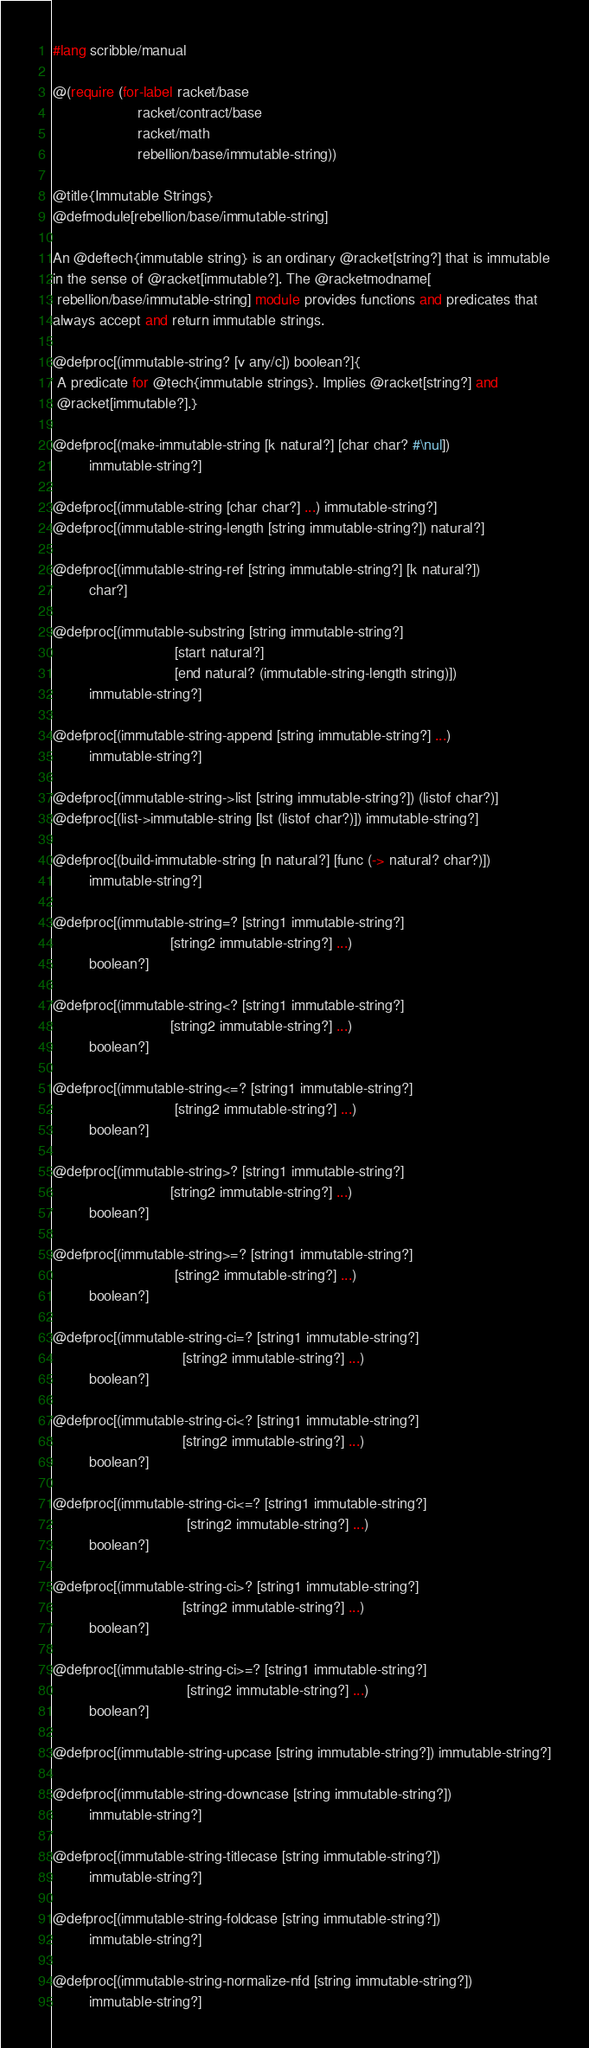Convert code to text. <code><loc_0><loc_0><loc_500><loc_500><_Racket_>#lang scribble/manual

@(require (for-label racket/base
                     racket/contract/base
                     racket/math
                     rebellion/base/immutable-string))

@title{Immutable Strings}
@defmodule[rebellion/base/immutable-string]

An @deftech{immutable string} is an ordinary @racket[string?] that is immutable
in the sense of @racket[immutable?]. The @racketmodname[
 rebellion/base/immutable-string] module provides functions and predicates that
always accept and return immutable strings.

@defproc[(immutable-string? [v any/c]) boolean?]{
 A predicate for @tech{immutable strings}. Implies @racket[string?] and
 @racket[immutable?].}

@defproc[(make-immutable-string [k natural?] [char char? #\nul])
         immutable-string?]

@defproc[(immutable-string [char char?] ...) immutable-string?]
@defproc[(immutable-string-length [string immutable-string?]) natural?]

@defproc[(immutable-string-ref [string immutable-string?] [k natural?])
         char?]

@defproc[(immutable-substring [string immutable-string?]
                              [start natural?]
                              [end natural? (immutable-string-length string)])
         immutable-string?]

@defproc[(immutable-string-append [string immutable-string?] ...)
         immutable-string?]

@defproc[(immutable-string->list [string immutable-string?]) (listof char?)]
@defproc[(list->immutable-string [lst (listof char?)]) immutable-string?]

@defproc[(build-immutable-string [n natural?] [func (-> natural? char?)])
         immutable-string?]

@defproc[(immutable-string=? [string1 immutable-string?]
                             [string2 immutable-string?] ...)
         boolean?]

@defproc[(immutable-string<? [string1 immutable-string?]
                             [string2 immutable-string?] ...)
         boolean?]

@defproc[(immutable-string<=? [string1 immutable-string?]
                              [string2 immutable-string?] ...)
         boolean?]

@defproc[(immutable-string>? [string1 immutable-string?]
                             [string2 immutable-string?] ...)
         boolean?]

@defproc[(immutable-string>=? [string1 immutable-string?]
                              [string2 immutable-string?] ...)
         boolean?]

@defproc[(immutable-string-ci=? [string1 immutable-string?]
                                [string2 immutable-string?] ...)
         boolean?]

@defproc[(immutable-string-ci<? [string1 immutable-string?]
                                [string2 immutable-string?] ...)
         boolean?]

@defproc[(immutable-string-ci<=? [string1 immutable-string?]
                                 [string2 immutable-string?] ...)
         boolean?]

@defproc[(immutable-string-ci>? [string1 immutable-string?]
                                [string2 immutable-string?] ...)
         boolean?]

@defproc[(immutable-string-ci>=? [string1 immutable-string?]
                                 [string2 immutable-string?] ...)
         boolean?]

@defproc[(immutable-string-upcase [string immutable-string?]) immutable-string?]

@defproc[(immutable-string-downcase [string immutable-string?])
         immutable-string?]

@defproc[(immutable-string-titlecase [string immutable-string?])
         immutable-string?]

@defproc[(immutable-string-foldcase [string immutable-string?])
         immutable-string?]

@defproc[(immutable-string-normalize-nfd [string immutable-string?])
         immutable-string?]
</code> 